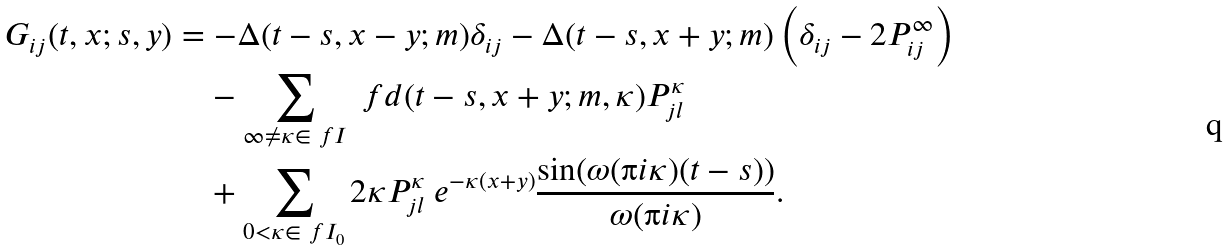Convert formula to latex. <formula><loc_0><loc_0><loc_500><loc_500>G _ { i j } ( t , x ; s , y ) & = - \Delta ( t - s , x - y ; m ) \delta _ { i j } - \Delta ( t - s , x + y ; m ) \left ( \delta _ { i j } - 2 P ^ { \infty } _ { i j } \right ) \\ & \quad - \sum _ { \infty \neq \kappa \in \ f I } \ f d ( t - s , x + y ; m , \kappa ) P ^ { \kappa } _ { j l } \\ & \quad + \sum _ { 0 < \kappa \in \ f I _ { 0 } } 2 \kappa P ^ { \kappa } _ { j l } \ e ^ { - \kappa ( x + y ) } \frac { \sin ( \omega ( \i i \kappa ) ( t - s ) ) } { \omega ( \i i \kappa ) } .</formula> 